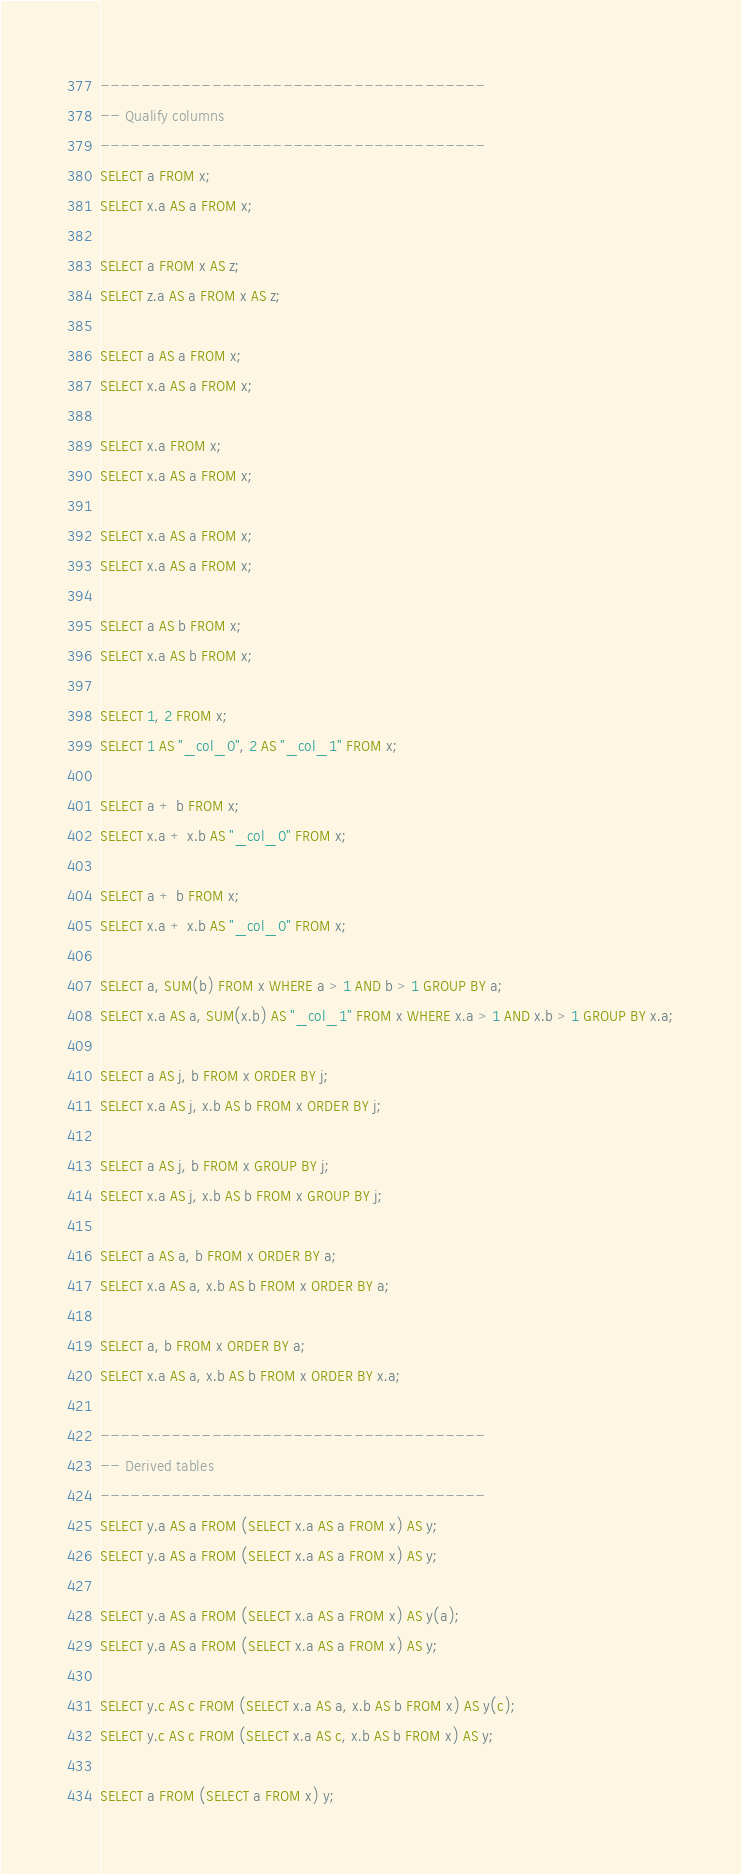<code> <loc_0><loc_0><loc_500><loc_500><_SQL_>--------------------------------------
-- Qualify columns
--------------------------------------
SELECT a FROM x;
SELECT x.a AS a FROM x;

SELECT a FROM x AS z;
SELECT z.a AS a FROM x AS z;

SELECT a AS a FROM x;
SELECT x.a AS a FROM x;

SELECT x.a FROM x;
SELECT x.a AS a FROM x;

SELECT x.a AS a FROM x;
SELECT x.a AS a FROM x;

SELECT a AS b FROM x;
SELECT x.a AS b FROM x;

SELECT 1, 2 FROM x;
SELECT 1 AS "_col_0", 2 AS "_col_1" FROM x;

SELECT a + b FROM x;
SELECT x.a + x.b AS "_col_0" FROM x;

SELECT a + b FROM x;
SELECT x.a + x.b AS "_col_0" FROM x;

SELECT a, SUM(b) FROM x WHERE a > 1 AND b > 1 GROUP BY a;
SELECT x.a AS a, SUM(x.b) AS "_col_1" FROM x WHERE x.a > 1 AND x.b > 1 GROUP BY x.a;

SELECT a AS j, b FROM x ORDER BY j;
SELECT x.a AS j, x.b AS b FROM x ORDER BY j;

SELECT a AS j, b FROM x GROUP BY j;
SELECT x.a AS j, x.b AS b FROM x GROUP BY j;

SELECT a AS a, b FROM x ORDER BY a;
SELECT x.a AS a, x.b AS b FROM x ORDER BY a;

SELECT a, b FROM x ORDER BY a;
SELECT x.a AS a, x.b AS b FROM x ORDER BY x.a;

--------------------------------------
-- Derived tables
--------------------------------------
SELECT y.a AS a FROM (SELECT x.a AS a FROM x) AS y;
SELECT y.a AS a FROM (SELECT x.a AS a FROM x) AS y;

SELECT y.a AS a FROM (SELECT x.a AS a FROM x) AS y(a);
SELECT y.a AS a FROM (SELECT x.a AS a FROM x) AS y;

SELECT y.c AS c FROM (SELECT x.a AS a, x.b AS b FROM x) AS y(c);
SELECT y.c AS c FROM (SELECT x.a AS c, x.b AS b FROM x) AS y;

SELECT a FROM (SELECT a FROM x) y;</code> 